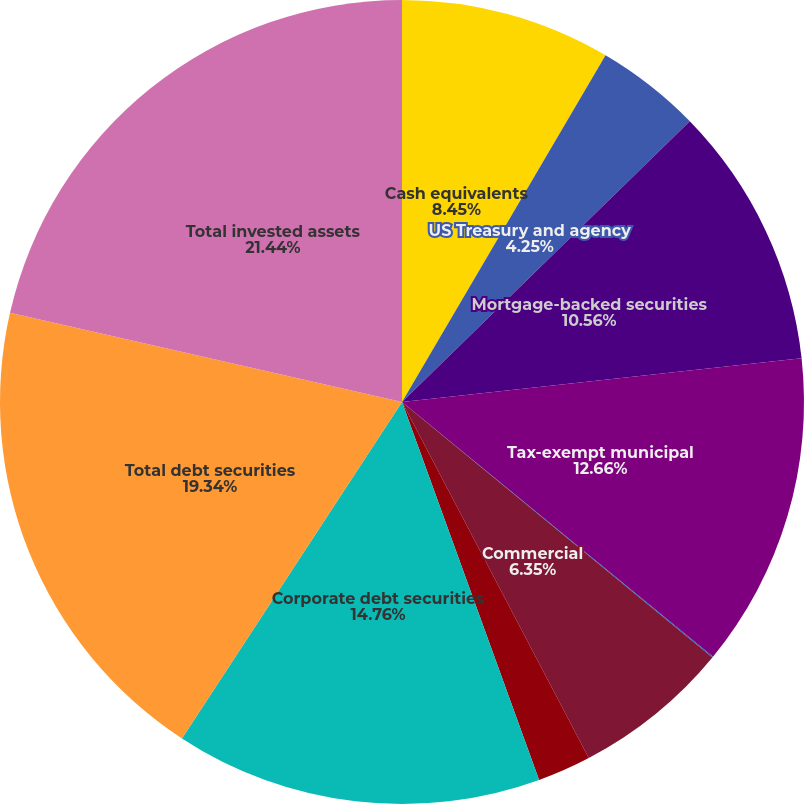<chart> <loc_0><loc_0><loc_500><loc_500><pie_chart><fcel>Cash equivalents<fcel>US Treasury and agency<fcel>Mortgage-backed securities<fcel>Tax-exempt municipal<fcel>Residential<fcel>Commercial<fcel>Asset-backed securities<fcel>Corporate debt securities<fcel>Total debt securities<fcel>Total invested assets<nl><fcel>8.45%<fcel>4.25%<fcel>10.56%<fcel>12.66%<fcel>0.04%<fcel>6.35%<fcel>2.15%<fcel>14.76%<fcel>19.34%<fcel>21.44%<nl></chart> 